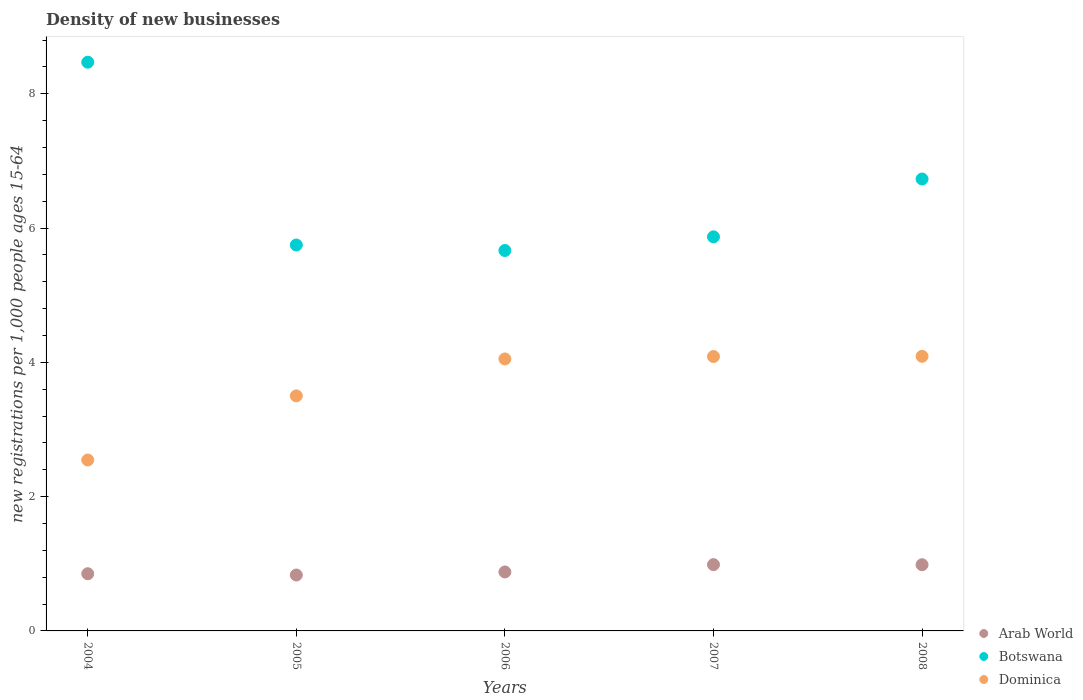What is the number of new registrations in Arab World in 2005?
Give a very brief answer. 0.83. Across all years, what is the maximum number of new registrations in Arab World?
Your answer should be compact. 0.99. Across all years, what is the minimum number of new registrations in Dominica?
Provide a succinct answer. 2.55. In which year was the number of new registrations in Dominica maximum?
Offer a very short reply. 2008. In which year was the number of new registrations in Botswana minimum?
Ensure brevity in your answer.  2006. What is the total number of new registrations in Botswana in the graph?
Offer a terse response. 32.49. What is the difference between the number of new registrations in Dominica in 2005 and that in 2008?
Offer a terse response. -0.59. What is the difference between the number of new registrations in Dominica in 2006 and the number of new registrations in Arab World in 2004?
Provide a short and direct response. 3.2. What is the average number of new registrations in Botswana per year?
Your answer should be very brief. 6.5. In the year 2007, what is the difference between the number of new registrations in Arab World and number of new registrations in Dominica?
Your answer should be compact. -3.1. In how many years, is the number of new registrations in Botswana greater than 6.4?
Offer a very short reply. 2. What is the ratio of the number of new registrations in Dominica in 2004 to that in 2005?
Keep it short and to the point. 0.73. Is the number of new registrations in Arab World in 2006 less than that in 2008?
Your answer should be very brief. Yes. What is the difference between the highest and the second highest number of new registrations in Dominica?
Ensure brevity in your answer.  0. What is the difference between the highest and the lowest number of new registrations in Botswana?
Make the answer very short. 2.8. Is the sum of the number of new registrations in Dominica in 2007 and 2008 greater than the maximum number of new registrations in Arab World across all years?
Provide a succinct answer. Yes. Is it the case that in every year, the sum of the number of new registrations in Arab World and number of new registrations in Botswana  is greater than the number of new registrations in Dominica?
Offer a terse response. Yes. Is the number of new registrations in Dominica strictly greater than the number of new registrations in Arab World over the years?
Offer a terse response. Yes. Is the number of new registrations in Botswana strictly less than the number of new registrations in Dominica over the years?
Provide a short and direct response. No. How many dotlines are there?
Your answer should be compact. 3. Does the graph contain any zero values?
Give a very brief answer. No. Where does the legend appear in the graph?
Your answer should be compact. Bottom right. How many legend labels are there?
Ensure brevity in your answer.  3. How are the legend labels stacked?
Keep it short and to the point. Vertical. What is the title of the graph?
Provide a short and direct response. Density of new businesses. Does "Honduras" appear as one of the legend labels in the graph?
Your answer should be compact. No. What is the label or title of the Y-axis?
Give a very brief answer. New registrations per 1,0 people ages 15-64. What is the new registrations per 1,000 people ages 15-64 of Arab World in 2004?
Ensure brevity in your answer.  0.85. What is the new registrations per 1,000 people ages 15-64 of Botswana in 2004?
Your response must be concise. 8.47. What is the new registrations per 1,000 people ages 15-64 in Dominica in 2004?
Provide a short and direct response. 2.55. What is the new registrations per 1,000 people ages 15-64 of Arab World in 2005?
Make the answer very short. 0.83. What is the new registrations per 1,000 people ages 15-64 of Botswana in 2005?
Your answer should be very brief. 5.75. What is the new registrations per 1,000 people ages 15-64 of Dominica in 2005?
Ensure brevity in your answer.  3.5. What is the new registrations per 1,000 people ages 15-64 in Arab World in 2006?
Offer a very short reply. 0.88. What is the new registrations per 1,000 people ages 15-64 of Botswana in 2006?
Ensure brevity in your answer.  5.67. What is the new registrations per 1,000 people ages 15-64 in Dominica in 2006?
Give a very brief answer. 4.05. What is the new registrations per 1,000 people ages 15-64 in Arab World in 2007?
Make the answer very short. 0.99. What is the new registrations per 1,000 people ages 15-64 of Botswana in 2007?
Your answer should be compact. 5.87. What is the new registrations per 1,000 people ages 15-64 in Dominica in 2007?
Your answer should be very brief. 4.09. What is the new registrations per 1,000 people ages 15-64 in Arab World in 2008?
Offer a terse response. 0.99. What is the new registrations per 1,000 people ages 15-64 of Botswana in 2008?
Your response must be concise. 6.73. What is the new registrations per 1,000 people ages 15-64 in Dominica in 2008?
Offer a terse response. 4.09. Across all years, what is the maximum new registrations per 1,000 people ages 15-64 in Arab World?
Your answer should be compact. 0.99. Across all years, what is the maximum new registrations per 1,000 people ages 15-64 of Botswana?
Provide a succinct answer. 8.47. Across all years, what is the maximum new registrations per 1,000 people ages 15-64 in Dominica?
Ensure brevity in your answer.  4.09. Across all years, what is the minimum new registrations per 1,000 people ages 15-64 of Arab World?
Offer a very short reply. 0.83. Across all years, what is the minimum new registrations per 1,000 people ages 15-64 in Botswana?
Offer a terse response. 5.67. Across all years, what is the minimum new registrations per 1,000 people ages 15-64 in Dominica?
Make the answer very short. 2.55. What is the total new registrations per 1,000 people ages 15-64 of Arab World in the graph?
Provide a succinct answer. 4.54. What is the total new registrations per 1,000 people ages 15-64 of Botswana in the graph?
Provide a succinct answer. 32.49. What is the total new registrations per 1,000 people ages 15-64 of Dominica in the graph?
Make the answer very short. 18.28. What is the difference between the new registrations per 1,000 people ages 15-64 in Arab World in 2004 and that in 2005?
Give a very brief answer. 0.02. What is the difference between the new registrations per 1,000 people ages 15-64 in Botswana in 2004 and that in 2005?
Keep it short and to the point. 2.72. What is the difference between the new registrations per 1,000 people ages 15-64 in Dominica in 2004 and that in 2005?
Your answer should be very brief. -0.96. What is the difference between the new registrations per 1,000 people ages 15-64 of Arab World in 2004 and that in 2006?
Offer a very short reply. -0.03. What is the difference between the new registrations per 1,000 people ages 15-64 of Botswana in 2004 and that in 2006?
Provide a succinct answer. 2.8. What is the difference between the new registrations per 1,000 people ages 15-64 of Dominica in 2004 and that in 2006?
Keep it short and to the point. -1.51. What is the difference between the new registrations per 1,000 people ages 15-64 in Arab World in 2004 and that in 2007?
Ensure brevity in your answer.  -0.14. What is the difference between the new registrations per 1,000 people ages 15-64 of Botswana in 2004 and that in 2007?
Provide a short and direct response. 2.6. What is the difference between the new registrations per 1,000 people ages 15-64 of Dominica in 2004 and that in 2007?
Provide a succinct answer. -1.54. What is the difference between the new registrations per 1,000 people ages 15-64 in Arab World in 2004 and that in 2008?
Your answer should be compact. -0.13. What is the difference between the new registrations per 1,000 people ages 15-64 of Botswana in 2004 and that in 2008?
Make the answer very short. 1.74. What is the difference between the new registrations per 1,000 people ages 15-64 in Dominica in 2004 and that in 2008?
Your response must be concise. -1.54. What is the difference between the new registrations per 1,000 people ages 15-64 of Arab World in 2005 and that in 2006?
Provide a succinct answer. -0.05. What is the difference between the new registrations per 1,000 people ages 15-64 of Botswana in 2005 and that in 2006?
Keep it short and to the point. 0.08. What is the difference between the new registrations per 1,000 people ages 15-64 of Dominica in 2005 and that in 2006?
Offer a very short reply. -0.55. What is the difference between the new registrations per 1,000 people ages 15-64 in Arab World in 2005 and that in 2007?
Offer a terse response. -0.15. What is the difference between the new registrations per 1,000 people ages 15-64 of Botswana in 2005 and that in 2007?
Ensure brevity in your answer.  -0.12. What is the difference between the new registrations per 1,000 people ages 15-64 of Dominica in 2005 and that in 2007?
Your answer should be compact. -0.59. What is the difference between the new registrations per 1,000 people ages 15-64 of Arab World in 2005 and that in 2008?
Offer a terse response. -0.15. What is the difference between the new registrations per 1,000 people ages 15-64 in Botswana in 2005 and that in 2008?
Ensure brevity in your answer.  -0.98. What is the difference between the new registrations per 1,000 people ages 15-64 in Dominica in 2005 and that in 2008?
Your answer should be very brief. -0.59. What is the difference between the new registrations per 1,000 people ages 15-64 of Arab World in 2006 and that in 2007?
Ensure brevity in your answer.  -0.11. What is the difference between the new registrations per 1,000 people ages 15-64 in Botswana in 2006 and that in 2007?
Offer a terse response. -0.2. What is the difference between the new registrations per 1,000 people ages 15-64 in Dominica in 2006 and that in 2007?
Your answer should be compact. -0.04. What is the difference between the new registrations per 1,000 people ages 15-64 in Arab World in 2006 and that in 2008?
Make the answer very short. -0.11. What is the difference between the new registrations per 1,000 people ages 15-64 of Botswana in 2006 and that in 2008?
Give a very brief answer. -1.06. What is the difference between the new registrations per 1,000 people ages 15-64 of Dominica in 2006 and that in 2008?
Give a very brief answer. -0.04. What is the difference between the new registrations per 1,000 people ages 15-64 of Arab World in 2007 and that in 2008?
Offer a very short reply. 0. What is the difference between the new registrations per 1,000 people ages 15-64 in Botswana in 2007 and that in 2008?
Give a very brief answer. -0.86. What is the difference between the new registrations per 1,000 people ages 15-64 of Dominica in 2007 and that in 2008?
Provide a short and direct response. -0. What is the difference between the new registrations per 1,000 people ages 15-64 in Arab World in 2004 and the new registrations per 1,000 people ages 15-64 in Botswana in 2005?
Ensure brevity in your answer.  -4.9. What is the difference between the new registrations per 1,000 people ages 15-64 of Arab World in 2004 and the new registrations per 1,000 people ages 15-64 of Dominica in 2005?
Your answer should be compact. -2.65. What is the difference between the new registrations per 1,000 people ages 15-64 of Botswana in 2004 and the new registrations per 1,000 people ages 15-64 of Dominica in 2005?
Make the answer very short. 4.97. What is the difference between the new registrations per 1,000 people ages 15-64 in Arab World in 2004 and the new registrations per 1,000 people ages 15-64 in Botswana in 2006?
Your answer should be very brief. -4.81. What is the difference between the new registrations per 1,000 people ages 15-64 of Arab World in 2004 and the new registrations per 1,000 people ages 15-64 of Dominica in 2006?
Keep it short and to the point. -3.2. What is the difference between the new registrations per 1,000 people ages 15-64 of Botswana in 2004 and the new registrations per 1,000 people ages 15-64 of Dominica in 2006?
Your response must be concise. 4.42. What is the difference between the new registrations per 1,000 people ages 15-64 in Arab World in 2004 and the new registrations per 1,000 people ages 15-64 in Botswana in 2007?
Keep it short and to the point. -5.02. What is the difference between the new registrations per 1,000 people ages 15-64 in Arab World in 2004 and the new registrations per 1,000 people ages 15-64 in Dominica in 2007?
Give a very brief answer. -3.24. What is the difference between the new registrations per 1,000 people ages 15-64 of Botswana in 2004 and the new registrations per 1,000 people ages 15-64 of Dominica in 2007?
Your answer should be compact. 4.38. What is the difference between the new registrations per 1,000 people ages 15-64 in Arab World in 2004 and the new registrations per 1,000 people ages 15-64 in Botswana in 2008?
Offer a very short reply. -5.88. What is the difference between the new registrations per 1,000 people ages 15-64 of Arab World in 2004 and the new registrations per 1,000 people ages 15-64 of Dominica in 2008?
Provide a short and direct response. -3.24. What is the difference between the new registrations per 1,000 people ages 15-64 in Botswana in 2004 and the new registrations per 1,000 people ages 15-64 in Dominica in 2008?
Give a very brief answer. 4.38. What is the difference between the new registrations per 1,000 people ages 15-64 in Arab World in 2005 and the new registrations per 1,000 people ages 15-64 in Botswana in 2006?
Your answer should be very brief. -4.83. What is the difference between the new registrations per 1,000 people ages 15-64 of Arab World in 2005 and the new registrations per 1,000 people ages 15-64 of Dominica in 2006?
Provide a short and direct response. -3.22. What is the difference between the new registrations per 1,000 people ages 15-64 of Botswana in 2005 and the new registrations per 1,000 people ages 15-64 of Dominica in 2006?
Provide a succinct answer. 1.7. What is the difference between the new registrations per 1,000 people ages 15-64 in Arab World in 2005 and the new registrations per 1,000 people ages 15-64 in Botswana in 2007?
Ensure brevity in your answer.  -5.04. What is the difference between the new registrations per 1,000 people ages 15-64 in Arab World in 2005 and the new registrations per 1,000 people ages 15-64 in Dominica in 2007?
Your answer should be compact. -3.25. What is the difference between the new registrations per 1,000 people ages 15-64 in Botswana in 2005 and the new registrations per 1,000 people ages 15-64 in Dominica in 2007?
Make the answer very short. 1.66. What is the difference between the new registrations per 1,000 people ages 15-64 of Arab World in 2005 and the new registrations per 1,000 people ages 15-64 of Botswana in 2008?
Your answer should be very brief. -5.9. What is the difference between the new registrations per 1,000 people ages 15-64 in Arab World in 2005 and the new registrations per 1,000 people ages 15-64 in Dominica in 2008?
Give a very brief answer. -3.26. What is the difference between the new registrations per 1,000 people ages 15-64 in Botswana in 2005 and the new registrations per 1,000 people ages 15-64 in Dominica in 2008?
Provide a succinct answer. 1.66. What is the difference between the new registrations per 1,000 people ages 15-64 in Arab World in 2006 and the new registrations per 1,000 people ages 15-64 in Botswana in 2007?
Provide a short and direct response. -4.99. What is the difference between the new registrations per 1,000 people ages 15-64 of Arab World in 2006 and the new registrations per 1,000 people ages 15-64 of Dominica in 2007?
Offer a terse response. -3.21. What is the difference between the new registrations per 1,000 people ages 15-64 of Botswana in 2006 and the new registrations per 1,000 people ages 15-64 of Dominica in 2007?
Keep it short and to the point. 1.58. What is the difference between the new registrations per 1,000 people ages 15-64 in Arab World in 2006 and the new registrations per 1,000 people ages 15-64 in Botswana in 2008?
Your answer should be very brief. -5.85. What is the difference between the new registrations per 1,000 people ages 15-64 of Arab World in 2006 and the new registrations per 1,000 people ages 15-64 of Dominica in 2008?
Offer a very short reply. -3.21. What is the difference between the new registrations per 1,000 people ages 15-64 in Botswana in 2006 and the new registrations per 1,000 people ages 15-64 in Dominica in 2008?
Your answer should be compact. 1.58. What is the difference between the new registrations per 1,000 people ages 15-64 of Arab World in 2007 and the new registrations per 1,000 people ages 15-64 of Botswana in 2008?
Make the answer very short. -5.74. What is the difference between the new registrations per 1,000 people ages 15-64 of Arab World in 2007 and the new registrations per 1,000 people ages 15-64 of Dominica in 2008?
Your response must be concise. -3.1. What is the difference between the new registrations per 1,000 people ages 15-64 in Botswana in 2007 and the new registrations per 1,000 people ages 15-64 in Dominica in 2008?
Your answer should be compact. 1.78. What is the average new registrations per 1,000 people ages 15-64 of Arab World per year?
Make the answer very short. 0.91. What is the average new registrations per 1,000 people ages 15-64 of Botswana per year?
Your response must be concise. 6.5. What is the average new registrations per 1,000 people ages 15-64 of Dominica per year?
Offer a terse response. 3.66. In the year 2004, what is the difference between the new registrations per 1,000 people ages 15-64 of Arab World and new registrations per 1,000 people ages 15-64 of Botswana?
Provide a short and direct response. -7.62. In the year 2004, what is the difference between the new registrations per 1,000 people ages 15-64 in Arab World and new registrations per 1,000 people ages 15-64 in Dominica?
Your answer should be very brief. -1.69. In the year 2004, what is the difference between the new registrations per 1,000 people ages 15-64 of Botswana and new registrations per 1,000 people ages 15-64 of Dominica?
Your answer should be very brief. 5.93. In the year 2005, what is the difference between the new registrations per 1,000 people ages 15-64 of Arab World and new registrations per 1,000 people ages 15-64 of Botswana?
Offer a terse response. -4.92. In the year 2005, what is the difference between the new registrations per 1,000 people ages 15-64 in Arab World and new registrations per 1,000 people ages 15-64 in Dominica?
Your response must be concise. -2.67. In the year 2005, what is the difference between the new registrations per 1,000 people ages 15-64 of Botswana and new registrations per 1,000 people ages 15-64 of Dominica?
Your response must be concise. 2.25. In the year 2006, what is the difference between the new registrations per 1,000 people ages 15-64 of Arab World and new registrations per 1,000 people ages 15-64 of Botswana?
Offer a terse response. -4.79. In the year 2006, what is the difference between the new registrations per 1,000 people ages 15-64 in Arab World and new registrations per 1,000 people ages 15-64 in Dominica?
Make the answer very short. -3.17. In the year 2006, what is the difference between the new registrations per 1,000 people ages 15-64 of Botswana and new registrations per 1,000 people ages 15-64 of Dominica?
Keep it short and to the point. 1.62. In the year 2007, what is the difference between the new registrations per 1,000 people ages 15-64 of Arab World and new registrations per 1,000 people ages 15-64 of Botswana?
Your response must be concise. -4.88. In the year 2007, what is the difference between the new registrations per 1,000 people ages 15-64 of Arab World and new registrations per 1,000 people ages 15-64 of Dominica?
Provide a short and direct response. -3.1. In the year 2007, what is the difference between the new registrations per 1,000 people ages 15-64 in Botswana and new registrations per 1,000 people ages 15-64 in Dominica?
Keep it short and to the point. 1.78. In the year 2008, what is the difference between the new registrations per 1,000 people ages 15-64 in Arab World and new registrations per 1,000 people ages 15-64 in Botswana?
Ensure brevity in your answer.  -5.75. In the year 2008, what is the difference between the new registrations per 1,000 people ages 15-64 of Arab World and new registrations per 1,000 people ages 15-64 of Dominica?
Ensure brevity in your answer.  -3.1. In the year 2008, what is the difference between the new registrations per 1,000 people ages 15-64 in Botswana and new registrations per 1,000 people ages 15-64 in Dominica?
Offer a very short reply. 2.64. What is the ratio of the new registrations per 1,000 people ages 15-64 of Botswana in 2004 to that in 2005?
Keep it short and to the point. 1.47. What is the ratio of the new registrations per 1,000 people ages 15-64 of Dominica in 2004 to that in 2005?
Offer a very short reply. 0.73. What is the ratio of the new registrations per 1,000 people ages 15-64 of Arab World in 2004 to that in 2006?
Your response must be concise. 0.97. What is the ratio of the new registrations per 1,000 people ages 15-64 in Botswana in 2004 to that in 2006?
Provide a succinct answer. 1.49. What is the ratio of the new registrations per 1,000 people ages 15-64 in Dominica in 2004 to that in 2006?
Offer a very short reply. 0.63. What is the ratio of the new registrations per 1,000 people ages 15-64 in Arab World in 2004 to that in 2007?
Make the answer very short. 0.86. What is the ratio of the new registrations per 1,000 people ages 15-64 of Botswana in 2004 to that in 2007?
Offer a very short reply. 1.44. What is the ratio of the new registrations per 1,000 people ages 15-64 in Dominica in 2004 to that in 2007?
Give a very brief answer. 0.62. What is the ratio of the new registrations per 1,000 people ages 15-64 of Arab World in 2004 to that in 2008?
Provide a succinct answer. 0.86. What is the ratio of the new registrations per 1,000 people ages 15-64 in Botswana in 2004 to that in 2008?
Keep it short and to the point. 1.26. What is the ratio of the new registrations per 1,000 people ages 15-64 in Dominica in 2004 to that in 2008?
Keep it short and to the point. 0.62. What is the ratio of the new registrations per 1,000 people ages 15-64 of Arab World in 2005 to that in 2006?
Your answer should be compact. 0.95. What is the ratio of the new registrations per 1,000 people ages 15-64 in Botswana in 2005 to that in 2006?
Make the answer very short. 1.01. What is the ratio of the new registrations per 1,000 people ages 15-64 of Dominica in 2005 to that in 2006?
Keep it short and to the point. 0.86. What is the ratio of the new registrations per 1,000 people ages 15-64 in Arab World in 2005 to that in 2007?
Keep it short and to the point. 0.84. What is the ratio of the new registrations per 1,000 people ages 15-64 in Botswana in 2005 to that in 2007?
Your response must be concise. 0.98. What is the ratio of the new registrations per 1,000 people ages 15-64 in Dominica in 2005 to that in 2007?
Give a very brief answer. 0.86. What is the ratio of the new registrations per 1,000 people ages 15-64 in Arab World in 2005 to that in 2008?
Provide a succinct answer. 0.84. What is the ratio of the new registrations per 1,000 people ages 15-64 in Botswana in 2005 to that in 2008?
Your answer should be compact. 0.85. What is the ratio of the new registrations per 1,000 people ages 15-64 in Dominica in 2005 to that in 2008?
Give a very brief answer. 0.86. What is the ratio of the new registrations per 1,000 people ages 15-64 of Arab World in 2006 to that in 2007?
Offer a very short reply. 0.89. What is the ratio of the new registrations per 1,000 people ages 15-64 of Botswana in 2006 to that in 2007?
Your response must be concise. 0.97. What is the ratio of the new registrations per 1,000 people ages 15-64 of Arab World in 2006 to that in 2008?
Keep it short and to the point. 0.89. What is the ratio of the new registrations per 1,000 people ages 15-64 of Botswana in 2006 to that in 2008?
Keep it short and to the point. 0.84. What is the ratio of the new registrations per 1,000 people ages 15-64 of Dominica in 2006 to that in 2008?
Provide a short and direct response. 0.99. What is the ratio of the new registrations per 1,000 people ages 15-64 in Arab World in 2007 to that in 2008?
Your answer should be very brief. 1. What is the ratio of the new registrations per 1,000 people ages 15-64 of Botswana in 2007 to that in 2008?
Your response must be concise. 0.87. What is the difference between the highest and the second highest new registrations per 1,000 people ages 15-64 of Arab World?
Ensure brevity in your answer.  0. What is the difference between the highest and the second highest new registrations per 1,000 people ages 15-64 of Botswana?
Keep it short and to the point. 1.74. What is the difference between the highest and the second highest new registrations per 1,000 people ages 15-64 in Dominica?
Your answer should be very brief. 0. What is the difference between the highest and the lowest new registrations per 1,000 people ages 15-64 in Arab World?
Your response must be concise. 0.15. What is the difference between the highest and the lowest new registrations per 1,000 people ages 15-64 in Botswana?
Keep it short and to the point. 2.8. What is the difference between the highest and the lowest new registrations per 1,000 people ages 15-64 of Dominica?
Your answer should be compact. 1.54. 